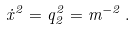Convert formula to latex. <formula><loc_0><loc_0><loc_500><loc_500>\dot { x } ^ { 2 } = q _ { 2 } ^ { 2 } = m ^ { - 2 } \, { . }</formula> 